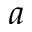<formula> <loc_0><loc_0><loc_500><loc_500>a</formula> 